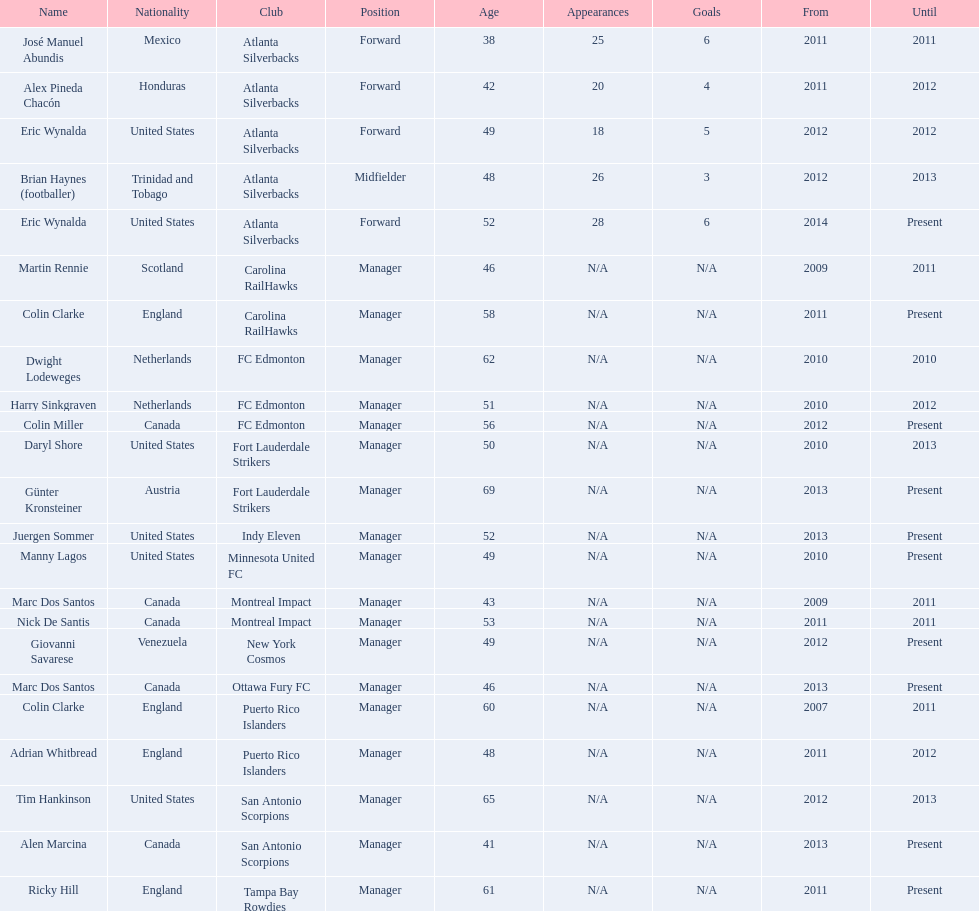What same country did marc dos santos coach as colin miller? Canada. 